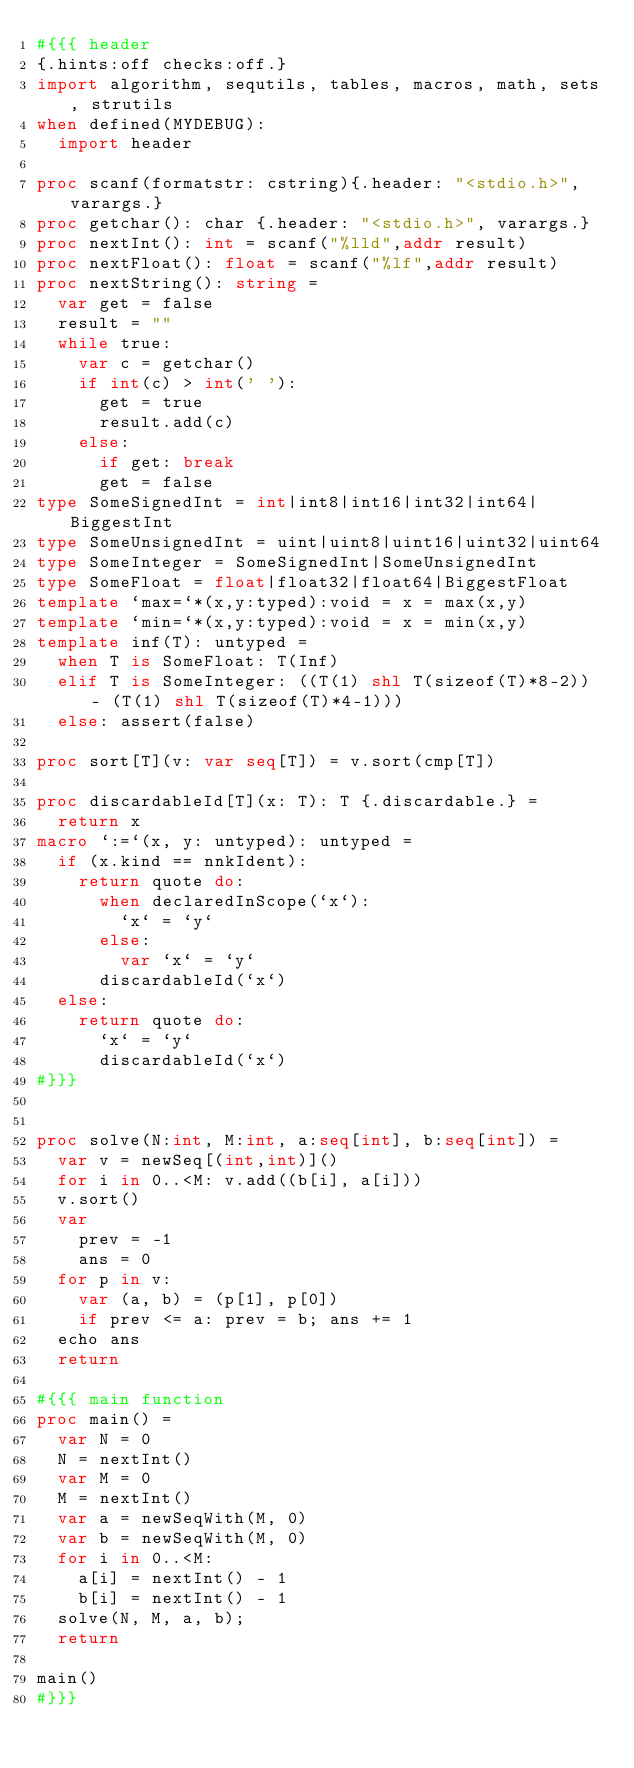<code> <loc_0><loc_0><loc_500><loc_500><_Nim_>#{{{ header
{.hints:off checks:off.}
import algorithm, sequtils, tables, macros, math, sets, strutils
when defined(MYDEBUG):
  import header

proc scanf(formatstr: cstring){.header: "<stdio.h>", varargs.}
proc getchar(): char {.header: "<stdio.h>", varargs.}
proc nextInt(): int = scanf("%lld",addr result)
proc nextFloat(): float = scanf("%lf",addr result)
proc nextString(): string =
  var get = false
  result = ""
  while true:
    var c = getchar()
    if int(c) > int(' '):
      get = true
      result.add(c)
    else:
      if get: break
      get = false
type SomeSignedInt = int|int8|int16|int32|int64|BiggestInt
type SomeUnsignedInt = uint|uint8|uint16|uint32|uint64
type SomeInteger = SomeSignedInt|SomeUnsignedInt
type SomeFloat = float|float32|float64|BiggestFloat
template `max=`*(x,y:typed):void = x = max(x,y)
template `min=`*(x,y:typed):void = x = min(x,y)
template inf(T): untyped = 
  when T is SomeFloat: T(Inf)
  elif T is SomeInteger: ((T(1) shl T(sizeof(T)*8-2)) - (T(1) shl T(sizeof(T)*4-1)))
  else: assert(false)

proc sort[T](v: var seq[T]) = v.sort(cmp[T])

proc discardableId[T](x: T): T {.discardable.} =
  return x
macro `:=`(x, y: untyped): untyped =
  if (x.kind == nnkIdent):
    return quote do:
      when declaredInScope(`x`):
        `x` = `y`
      else:
        var `x` = `y`
      discardableId(`x`)
  else:
    return quote do:
      `x` = `y`
      discardableId(`x`)
#}}}


proc solve(N:int, M:int, a:seq[int], b:seq[int]) =
  var v = newSeq[(int,int)]()
  for i in 0..<M: v.add((b[i], a[i]))
  v.sort()
  var
    prev = -1
    ans = 0
  for p in v:
    var (a, b) = (p[1], p[0])
    if prev <= a: prev = b; ans += 1
  echo ans
  return

#{{{ main function
proc main() =
  var N = 0
  N = nextInt()
  var M = 0
  M = nextInt()
  var a = newSeqWith(M, 0)
  var b = newSeqWith(M, 0)
  for i in 0..<M:
    a[i] = nextInt() - 1
    b[i] = nextInt() - 1
  solve(N, M, a, b);
  return

main()
#}}}
</code> 